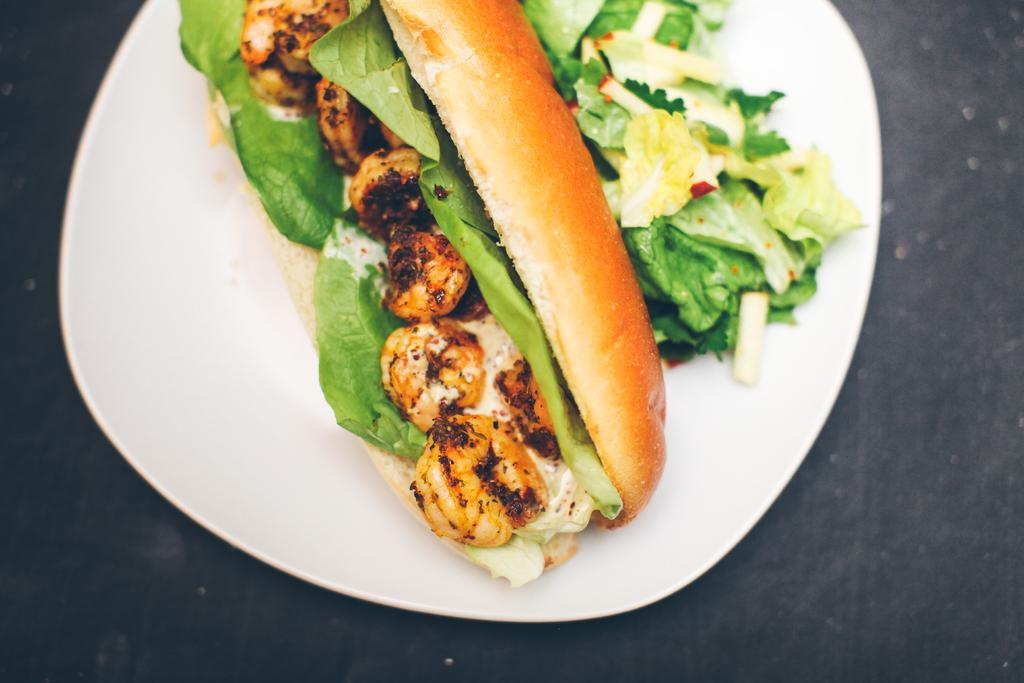What type of food is visible in the image? There is a hot dog in the image. On what is the hot dog placed? The hot dog is placed on a white plate. What is the name of the person who asked the question about the hot dog? The provided facts do not mention any names or people asking questions, so it is not possible to answer this question. 